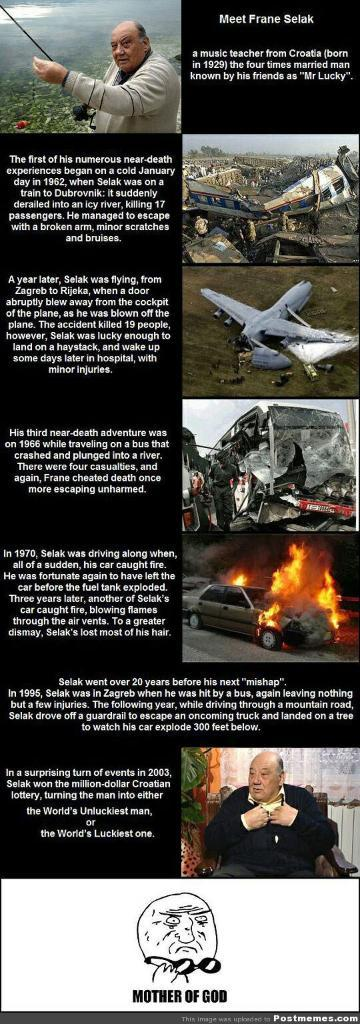What type of visual is the image? The image is a poster. How many people are depicted in the poster? There are two people depicted in the poster. What mode of transportation is featured in the poster? There is an airplane in the poster. What is an unusual event happening in the poster? There is a car on fire in the poster. What else can be seen in the poster besides the people and the airplane? There are various objects in the poster. Is there any text present in the poster? Yes, there is text present in the poster. What type of metal is used to make the whip in the poster? There is no whip present in the poster, so it is not possible to determine the type of metal used to make it. 